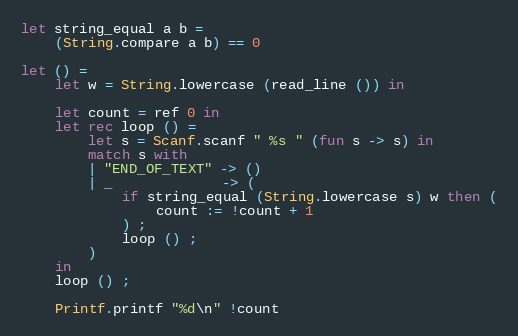Convert code to text. <code><loc_0><loc_0><loc_500><loc_500><_OCaml_>let string_equal a b =
    (String.compare a b) == 0

let () =
    let w = String.lowercase (read_line ()) in

    let count = ref 0 in
    let rec loop () =
        let s = Scanf.scanf " %s " (fun s -> s) in
        match s with
        | "END_OF_TEXT" -> ()
        | _             -> (
            if string_equal (String.lowercase s) w then (
                count := !count + 1
            ) ;
            loop () ;
        )
    in
    loop () ;

    Printf.printf "%d\n" !count</code> 